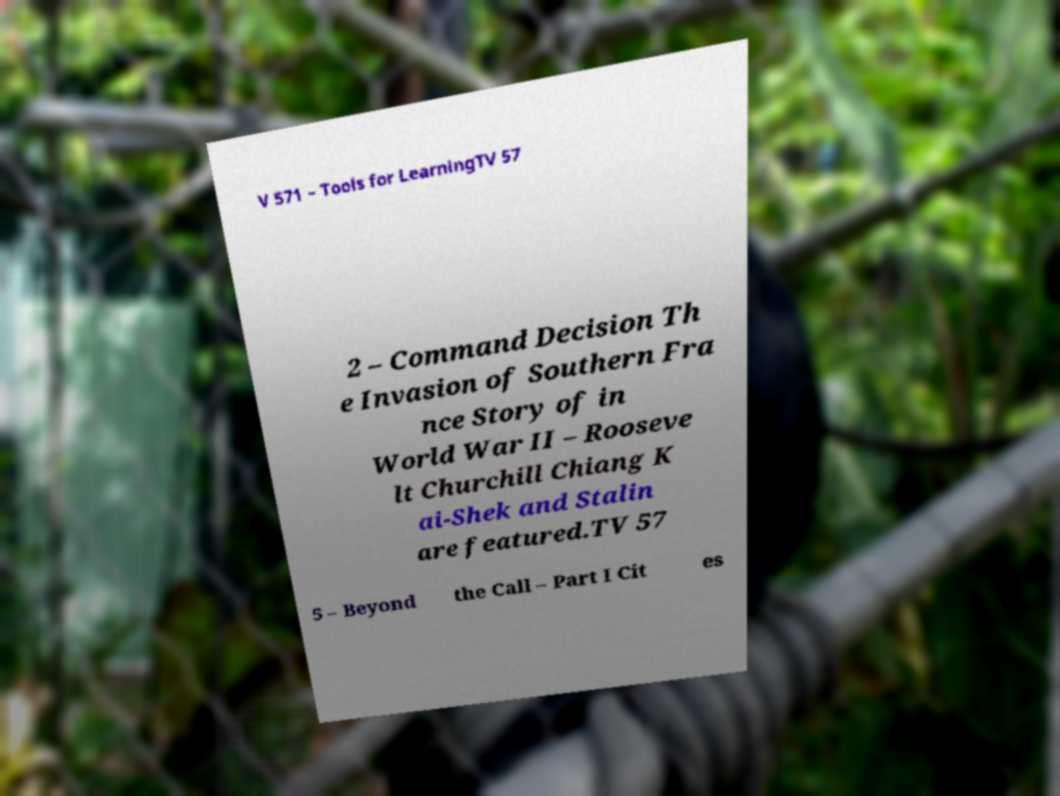For documentation purposes, I need the text within this image transcribed. Could you provide that? V 571 – Tools for LearningTV 57 2 – Command Decision Th e Invasion of Southern Fra nce Story of in World War II – Rooseve lt Churchill Chiang K ai-Shek and Stalin are featured.TV 57 5 – Beyond the Call – Part I Cit es 